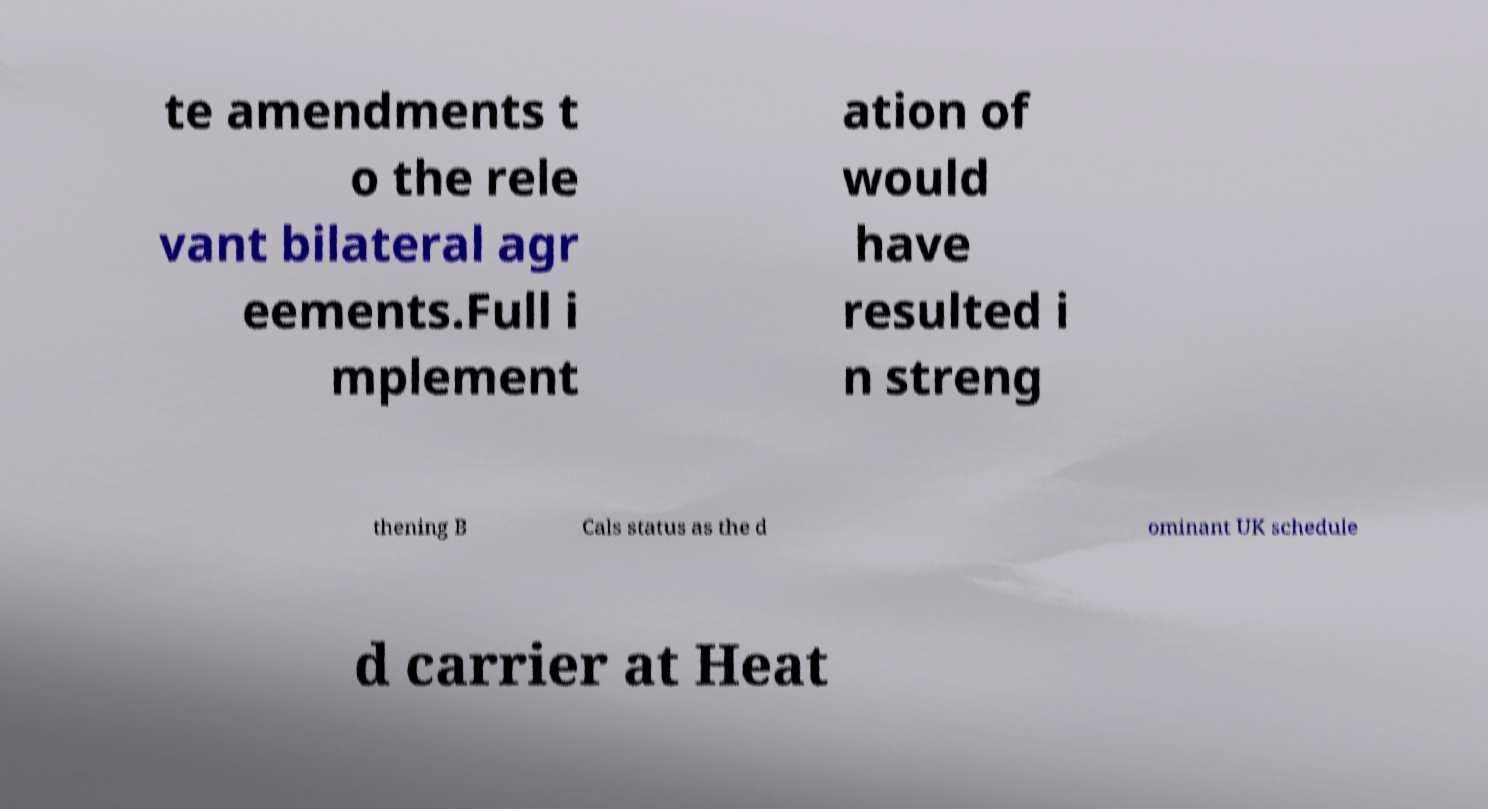Could you extract and type out the text from this image? te amendments t o the rele vant bilateral agr eements.Full i mplement ation of would have resulted i n streng thening B Cals status as the d ominant UK schedule d carrier at Heat 